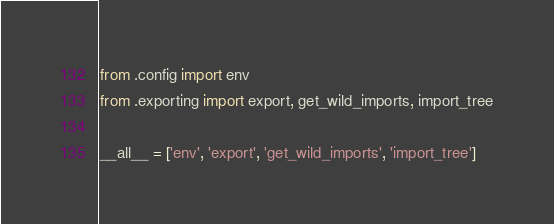<code> <loc_0><loc_0><loc_500><loc_500><_Python_>from .config import env
from .exporting import export, get_wild_imports, import_tree

__all__ = ['env', 'export', 'get_wild_imports', 'import_tree']
</code> 